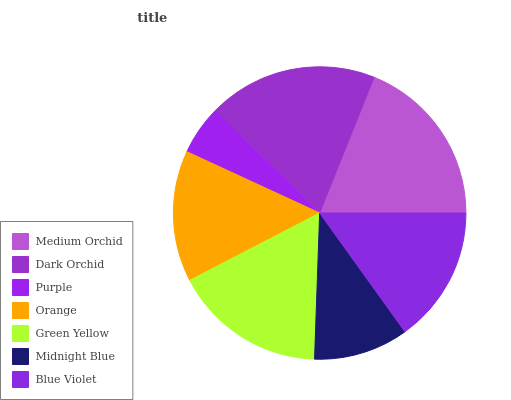Is Purple the minimum?
Answer yes or no. Yes. Is Medium Orchid the maximum?
Answer yes or no. Yes. Is Dark Orchid the minimum?
Answer yes or no. No. Is Dark Orchid the maximum?
Answer yes or no. No. Is Medium Orchid greater than Dark Orchid?
Answer yes or no. Yes. Is Dark Orchid less than Medium Orchid?
Answer yes or no. Yes. Is Dark Orchid greater than Medium Orchid?
Answer yes or no. No. Is Medium Orchid less than Dark Orchid?
Answer yes or no. No. Is Blue Violet the high median?
Answer yes or no. Yes. Is Blue Violet the low median?
Answer yes or no. Yes. Is Midnight Blue the high median?
Answer yes or no. No. Is Green Yellow the low median?
Answer yes or no. No. 